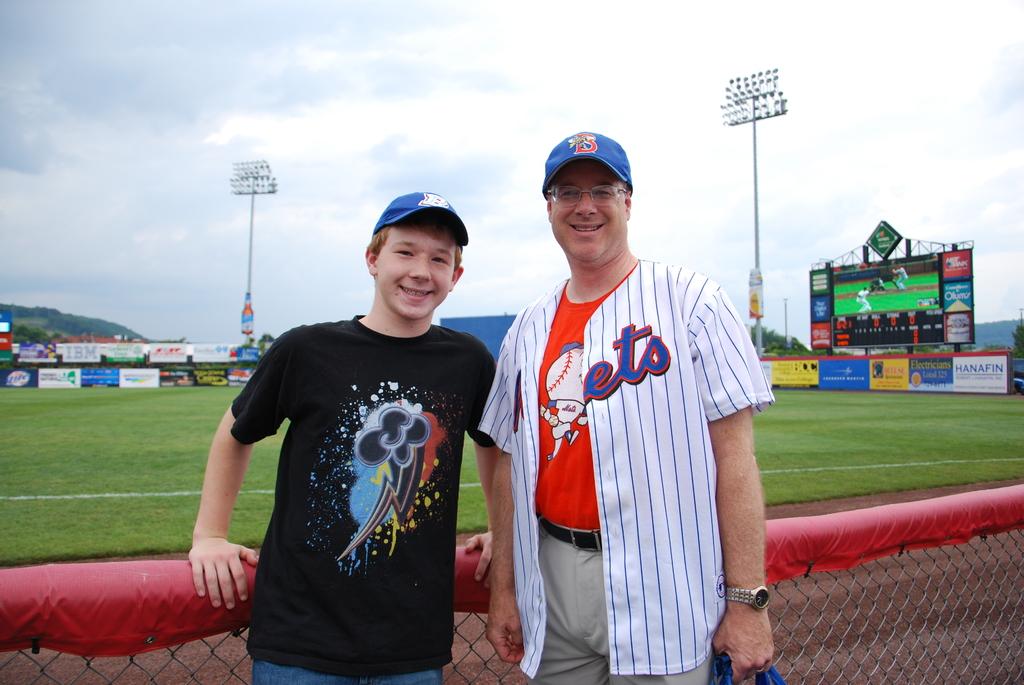What adverts are on the wall?
Offer a very short reply. Unanswerable. 